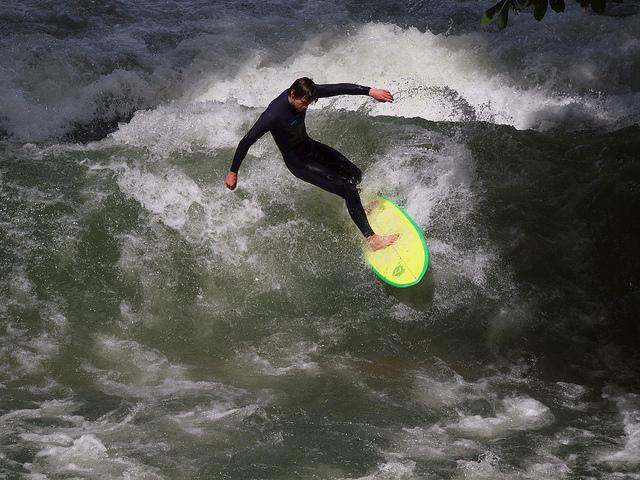What is the man doing?
Be succinct. Surfing. How many boards in the water?
Give a very brief answer. 1. Is it stormy?
Write a very short answer. No. 